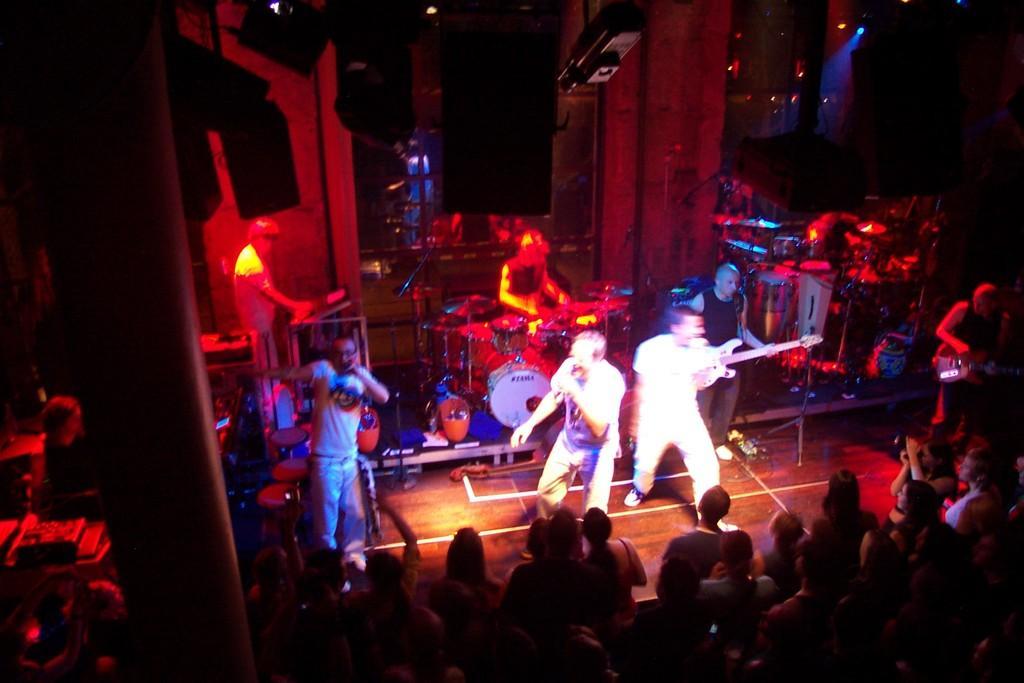Could you give a brief overview of what you see in this image? This picture describes about group of people, in the middle of the image we can see few people playing musical instruments, in the background we can find few lights and speakers. 